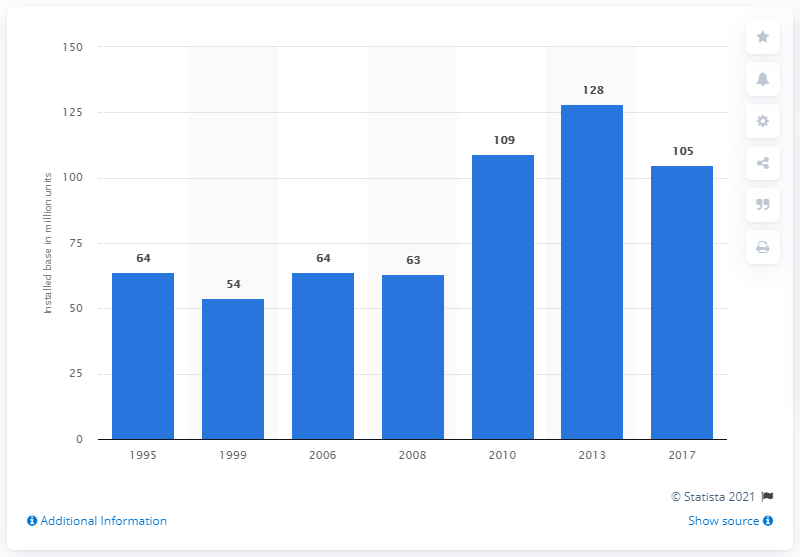Indicate a few pertinent items in this graphic. In 2017, the installed base of video game systems in the United States was approximately 105 million. 